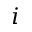<formula> <loc_0><loc_0><loc_500><loc_500>i</formula> 